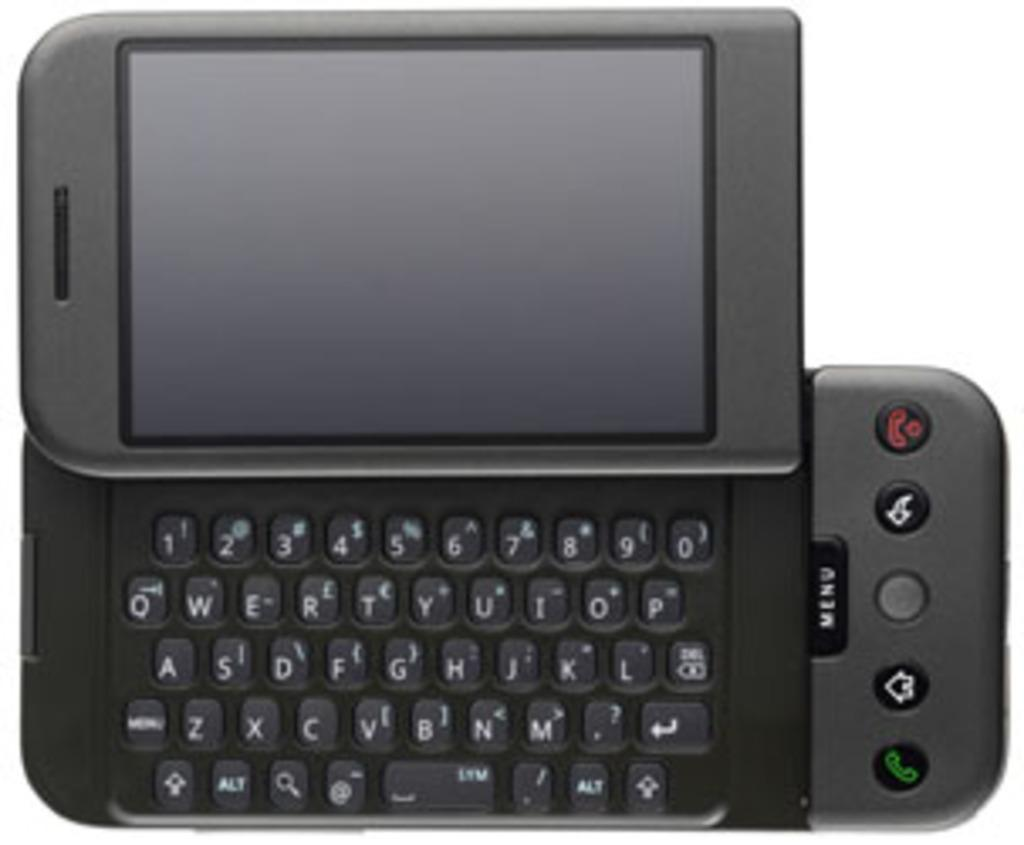<image>
Share a concise interpretation of the image provided. the letter O is on the black phone item 